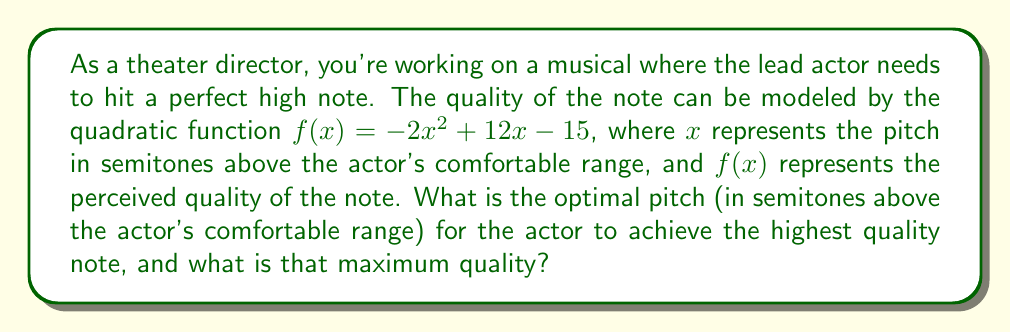Provide a solution to this math problem. To find the optimal pitch and maximum quality, we need to calculate the vertex of the parabola represented by the given quadratic function.

1) The quadratic function is in the form $f(x) = ax^2 + bx + c$, where:
   $a = -2$, $b = 12$, and $c = -15$

2) For a parabola, the x-coordinate of the vertex is given by the formula:
   $$x = -\frac{b}{2a}$$

3) Substituting our values:
   $$x = -\frac{12}{2(-2)} = -\frac{12}{-4} = 3$$

4) To find the y-coordinate (maximum quality), we substitute this x-value back into the original function:
   
   $f(3) = -2(3)^2 + 12(3) - 15$
   $= -2(9) + 36 - 15$
   $= -18 + 36 - 15$
   $= 3$

5) Therefore, the vertex of the parabola is at the point (3, 3).

This means the optimal pitch is 3 semitones above the actor's comfortable range, and the maximum quality achieved at this pitch is 3 units on the quality scale.
Answer: The optimal pitch is 3 semitones above the actor's comfortable range, and the maximum quality achieved is 3 units. 